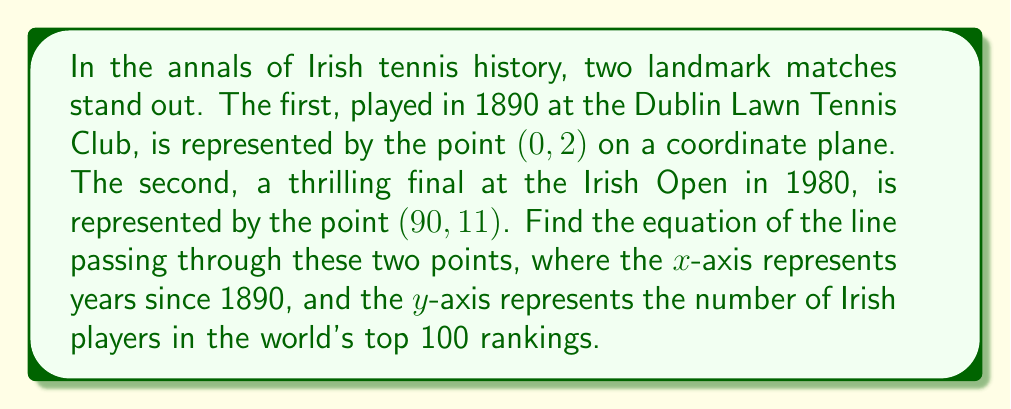What is the answer to this math problem? To find the equation of a line passing through two points, we'll use the point-slope form of a line: $y - y_1 = m(x - x_1)$, where $m$ is the slope of the line.

Step 1: Calculate the slope $(m)$ using the two given points.
$m = \frac{y_2 - y_1}{x_2 - x_1} = \frac{11 - 2}{90 - 0} = \frac{9}{90} = \frac{1}{10} = 0.1$

Step 2: Choose one of the points to use in the point-slope form. Let's use $(0, 2)$.

Step 3: Substitute the slope and chosen point into the point-slope form:
$y - 2 = 0.1(x - 0)$

Step 4: Simplify the equation:
$y - 2 = 0.1x$

Step 5: Rearrange to slope-intercept form $(y = mx + b)$:
$y = 0.1x + 2$

This equation represents the line passing through the two historic Irish tennis matches, where $x$ is the number of years since 1890, and $y$ is the number of Irish players in the world's top 100 rankings.
Answer: $y = 0.1x + 2$ 